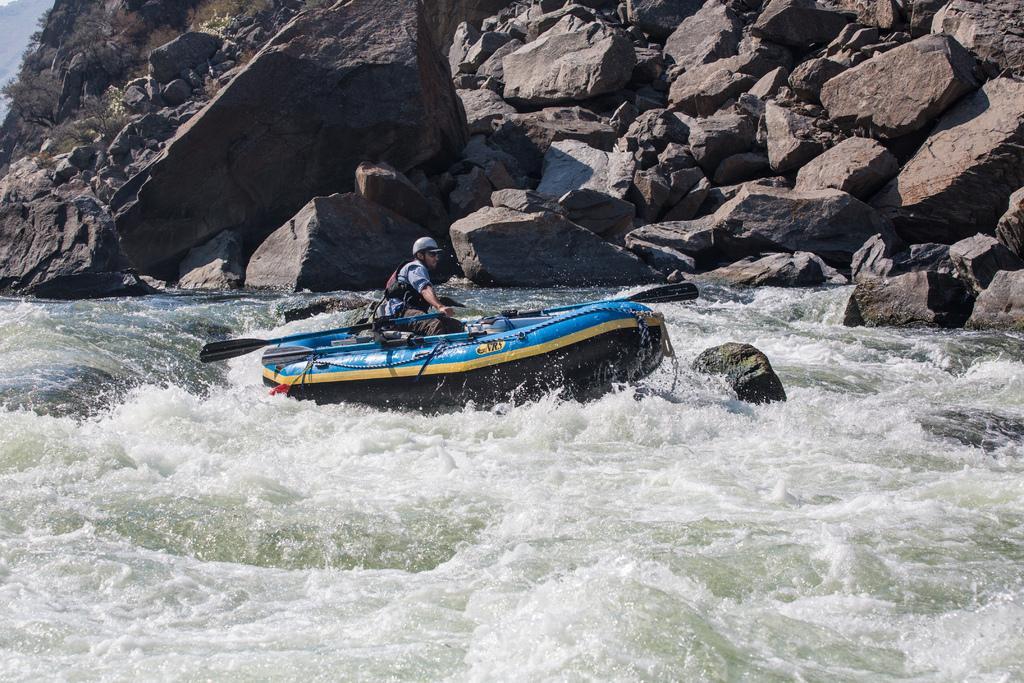In one or two sentences, can you explain what this image depicts? In the image in the center, we can see one boat. In the boat, we can see one person sitting and holding the paddle. In the background we can see water and hills. 